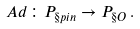<formula> <loc_0><loc_0><loc_500><loc_500>\ A d \colon P _ { \S p i n } \to P _ { \S O } \, .</formula> 